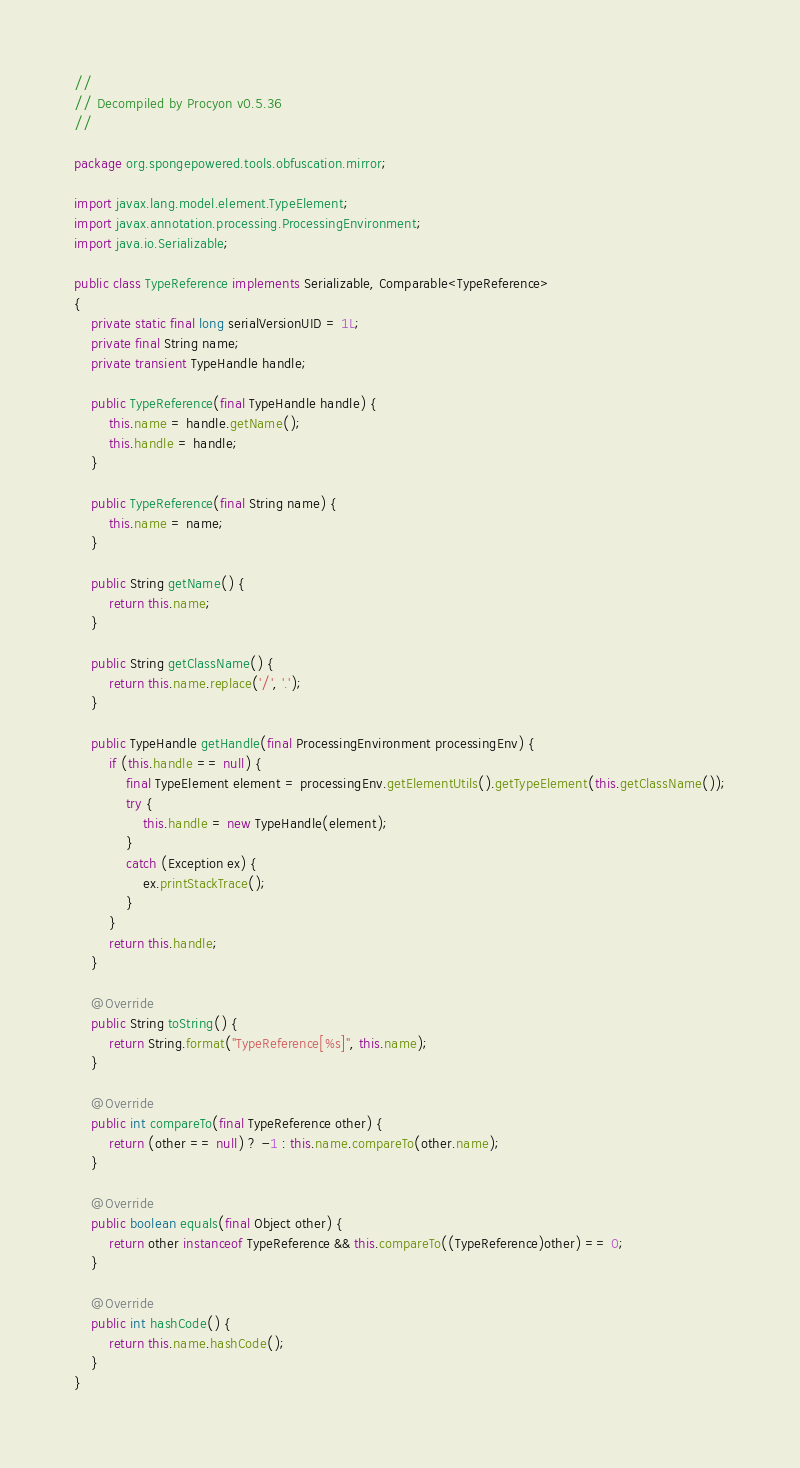Convert code to text. <code><loc_0><loc_0><loc_500><loc_500><_Java_>// 
// Decompiled by Procyon v0.5.36
// 

package org.spongepowered.tools.obfuscation.mirror;

import javax.lang.model.element.TypeElement;
import javax.annotation.processing.ProcessingEnvironment;
import java.io.Serializable;

public class TypeReference implements Serializable, Comparable<TypeReference>
{
    private static final long serialVersionUID = 1L;
    private final String name;
    private transient TypeHandle handle;
    
    public TypeReference(final TypeHandle handle) {
        this.name = handle.getName();
        this.handle = handle;
    }
    
    public TypeReference(final String name) {
        this.name = name;
    }
    
    public String getName() {
        return this.name;
    }
    
    public String getClassName() {
        return this.name.replace('/', '.');
    }
    
    public TypeHandle getHandle(final ProcessingEnvironment processingEnv) {
        if (this.handle == null) {
            final TypeElement element = processingEnv.getElementUtils().getTypeElement(this.getClassName());
            try {
                this.handle = new TypeHandle(element);
            }
            catch (Exception ex) {
                ex.printStackTrace();
            }
        }
        return this.handle;
    }
    
    @Override
    public String toString() {
        return String.format("TypeReference[%s]", this.name);
    }
    
    @Override
    public int compareTo(final TypeReference other) {
        return (other == null) ? -1 : this.name.compareTo(other.name);
    }
    
    @Override
    public boolean equals(final Object other) {
        return other instanceof TypeReference && this.compareTo((TypeReference)other) == 0;
    }
    
    @Override
    public int hashCode() {
        return this.name.hashCode();
    }
}
</code> 